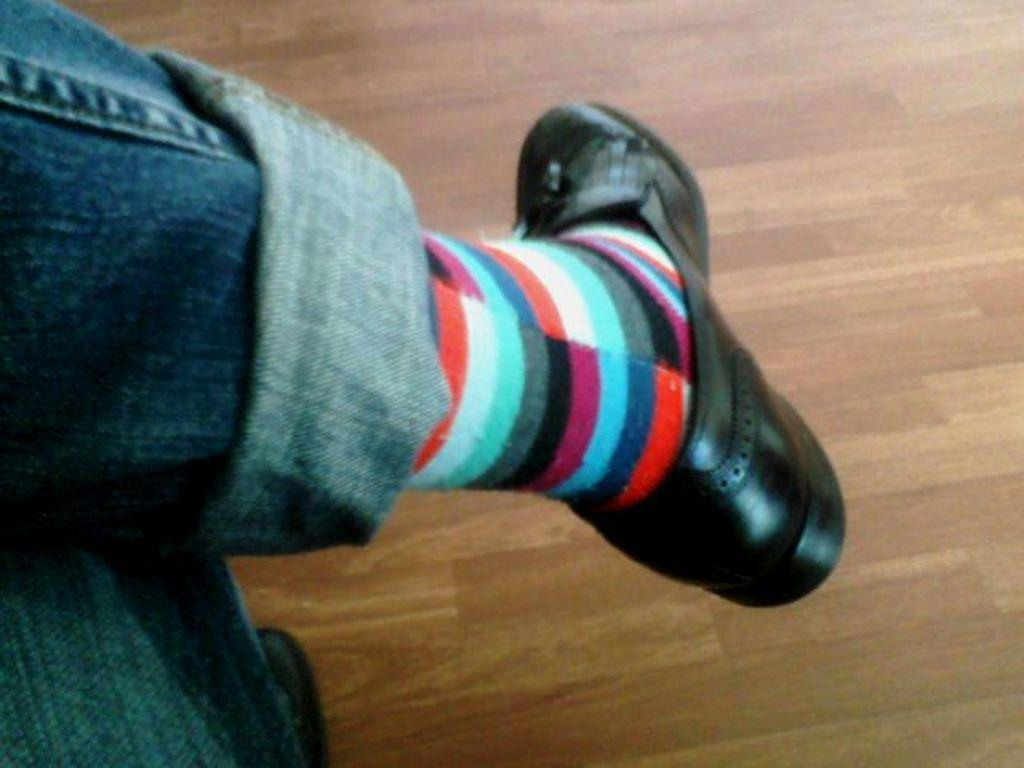What part of a person can be seen in the image? There are a person's legs visible in the image. What type of surface is the person's legs standing on? The floor is visible in the image. How many children are playing with the cable in the image? There are no children or cables present in the image. 